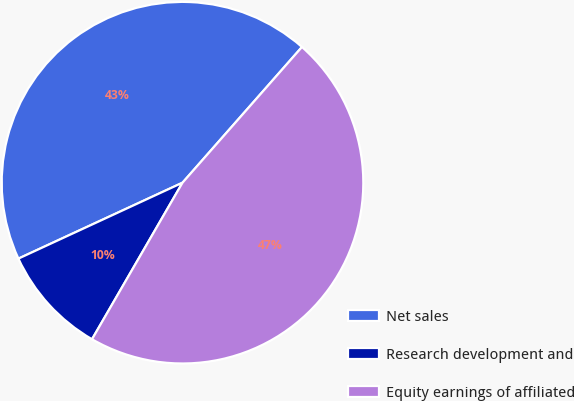Convert chart. <chart><loc_0><loc_0><loc_500><loc_500><pie_chart><fcel>Net sales<fcel>Research development and<fcel>Equity earnings of affiliated<nl><fcel>43.38%<fcel>9.76%<fcel>46.85%<nl></chart> 